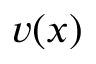Convert formula to latex. <formula><loc_0><loc_0><loc_500><loc_500>v ( x )</formula> 